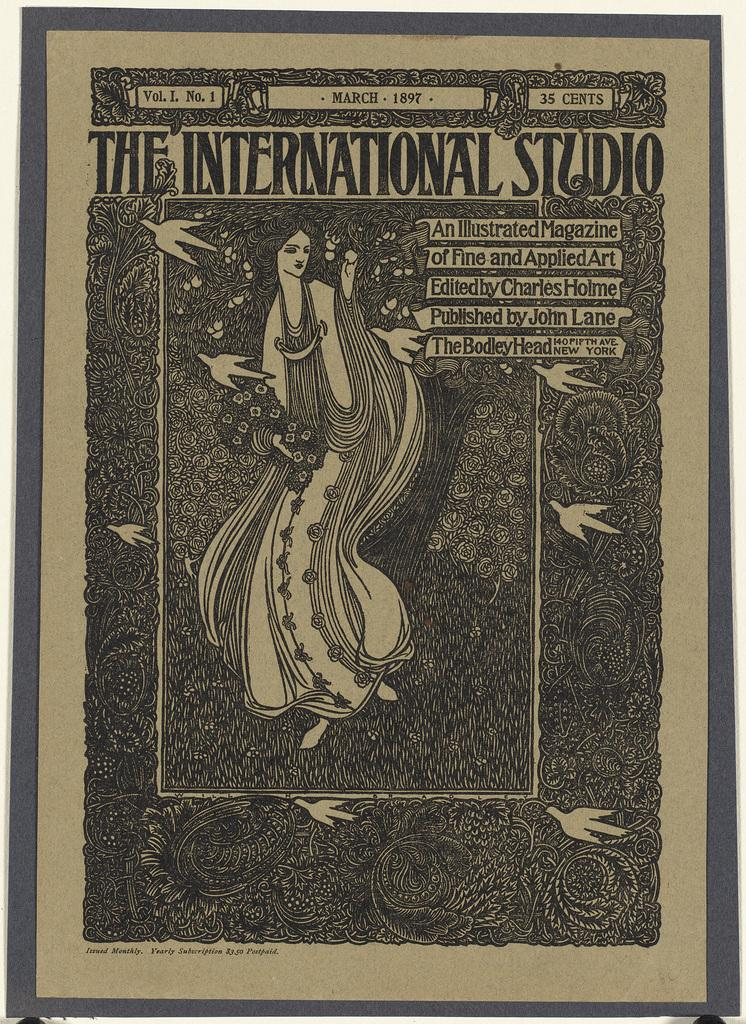What is the main subject of the image? There is an art of a woman in the image. Is there any text present in the image? Yes, there is text written at the top of the image. Can you see a plane flying in the image? No, there is no plane visible in the image. Is there a shop featured in the image? No, there is no shop present in the image. 